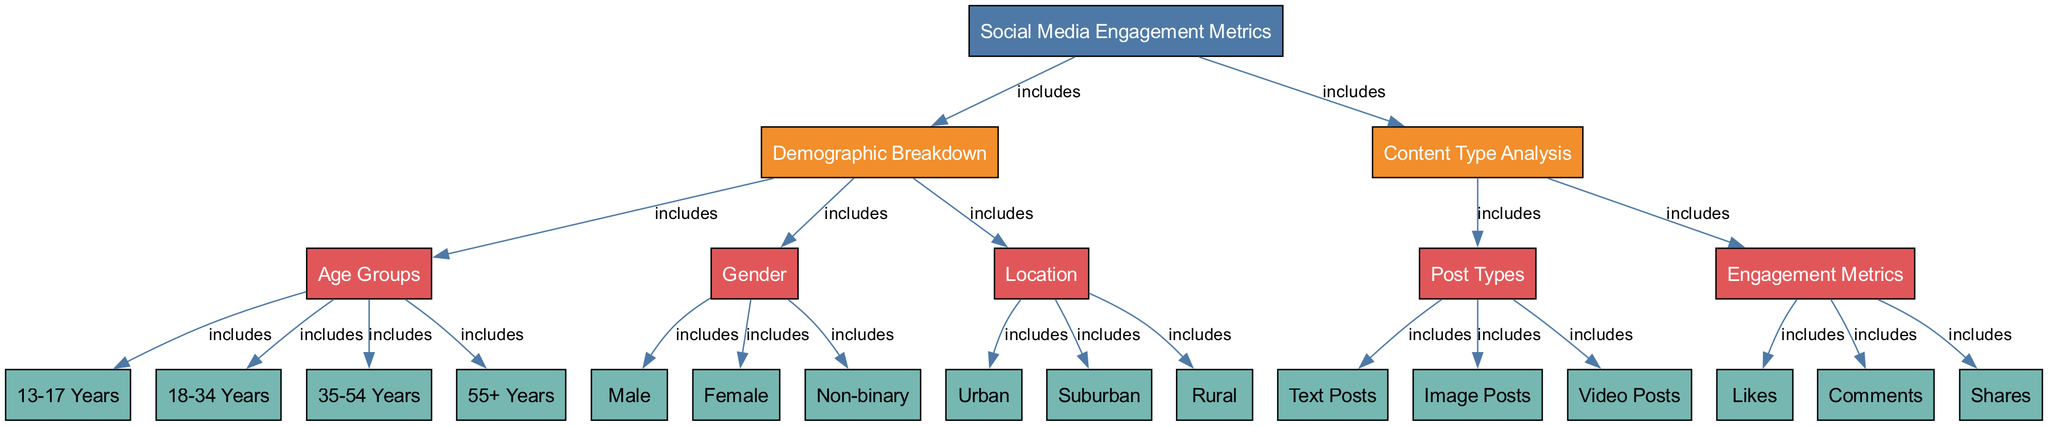What is the main category of the diagram? The main node of the diagram is labeled "Social Media Engagement Metrics," which represents the primary focus of the diagram.
Answer: Social Media Engagement Metrics How many demographic breakdown subcategories are included? The diagram includes three subcategories under the demographic breakdown: Age Groups, Gender, and Location. Counting these gives us three subcategories.
Answer: 3 What types of content analysis are represented in the diagram? The diagram lists Post Types and Engagement Metrics as the two main types of content analysis, showing what aspects of the content are being assessed.
Answer: Post Types, Engagement Metrics Which age group is labeled as "35-54 Years"? The "35-54 Years" node falls within the demographic breakdown of age groups, specifically indicating a range between 35 and 54 years.
Answer: 35-54 Years What are the main engagement metrics shown? The engagement metrics are shown as Likes, Comments, and Shares under the Engagement Metrics category, which reflect interaction with the content.
Answer: Likes, Comments, Shares Which demographic includes non-binary individuals? The subcategory labeled "Non-binary" falls under the Gender demographic breakdown, indicating that it is a recognized group in this context.
Answer: Non-binary Are urban and rural demographics included? Yes, both "Urban" and "Rural" are included as specific subcategories under the Location section, representing different geographical demographics.
Answer: Yes What is the relationship between Social Media Engagement Metrics and Content Type Analysis? The diagram shows that Social Media Engagement Metrics include Content Type Analysis, meaning that the metrics are based on the types of content being analyzed.
Answer: includes How many different types of post types are included? The diagram displays three types of post types: Text Posts, Image Posts, and Video Posts, showing a diverse range of content types scheduled for engagement analysis.
Answer: 3 What is the label for the first demographic subgroup under Age Groups? The first demographic subgroup under Age Groups is labeled "13-17 Years," indicating the youngest age range in the dataset.
Answer: 13-17 Years 